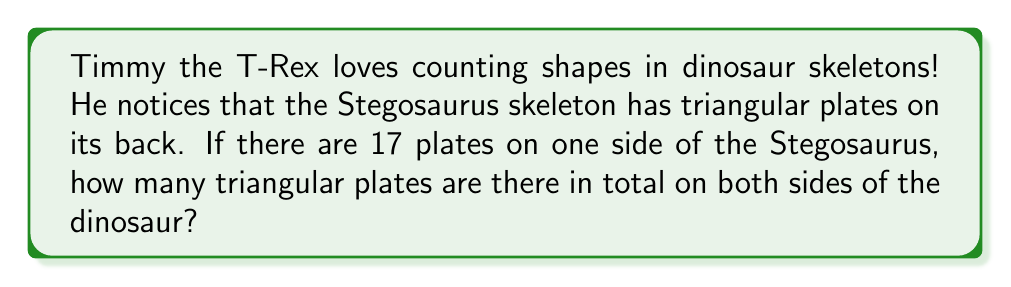Provide a solution to this math problem. Let's break this down into simple steps:

1. First, we need to understand that the Stegosaurus has plates on both sides of its body.

2. We're told that there are 17 plates on one side.

3. To find the total number of plates, we need to add the plates from both sides together.

4. Since the plates are symmetrical (the same on both sides), we can multiply the number of plates on one side by 2.

5. We can write this as a simple multiplication:

   $$ \text{Total plates} = 17 \times 2 $$

6. Now, let's solve this multiplication:

   $$ 17 \times 2 = 34 $$

So, there are 34 triangular plates in total on both sides of the Stegosaurus skeleton.
Answer: $34$ triangular plates 